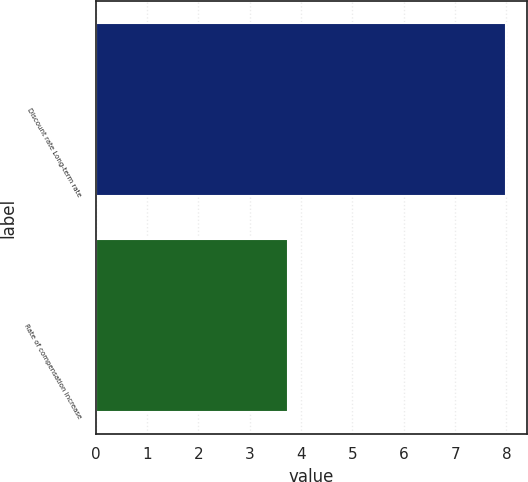<chart> <loc_0><loc_0><loc_500><loc_500><bar_chart><fcel>Discount rate Long-term rate<fcel>Rate of compensation increase<nl><fcel>8<fcel>3.75<nl></chart> 